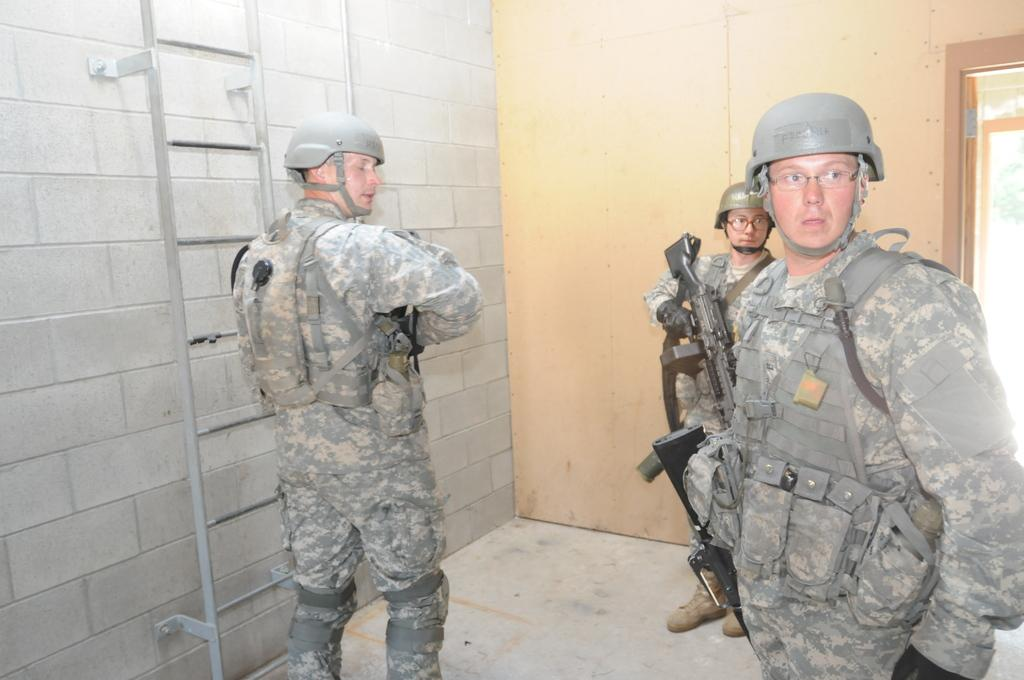What is the main subject of the image? The main subject of the image is a group of men. What are the men doing in the image? The men are standing and holding guns. What can be seen on the left side of the image? There is a ladder on the left side of the image. What is visible in the background of the image? There is a door and a wall in the background of the image. What type of sleet can be seen falling from the sky in the image? There is no sleet visible in the image; the sky is not mentioned in the provided facts. How many crates are present in the image? There is no crate present in the image; only a ladder, a door, and a wall are mentioned. 